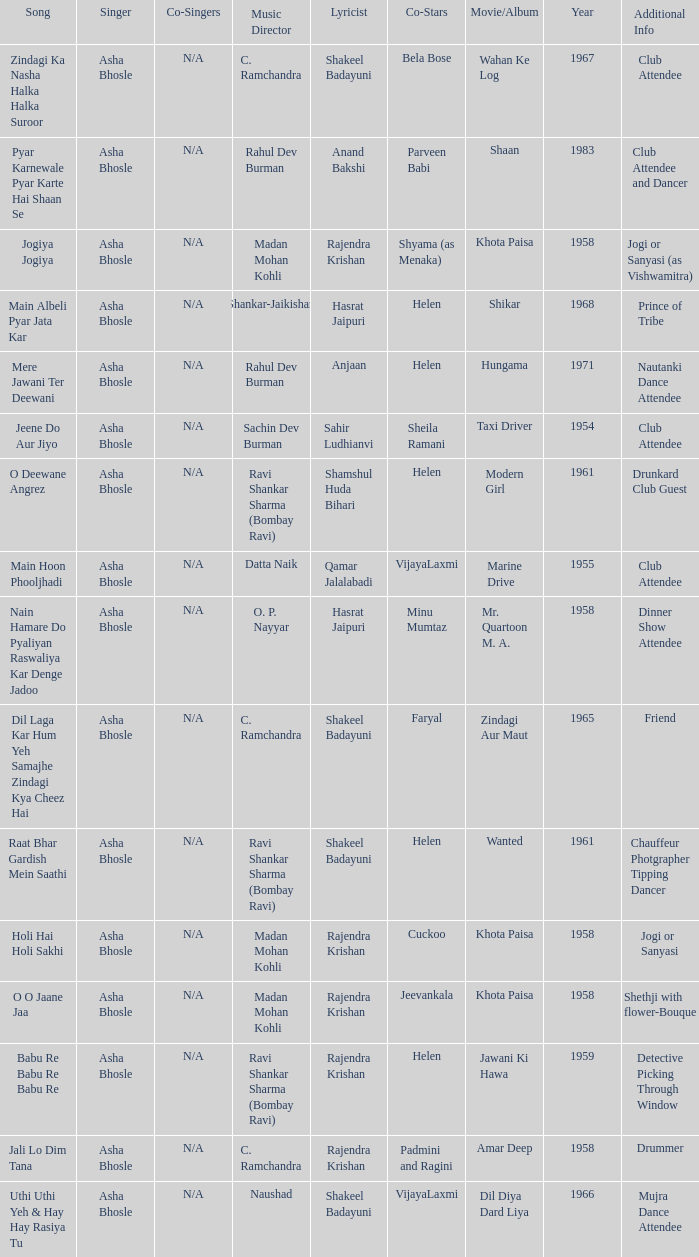Write the full table. {'header': ['Song', 'Singer', 'Co-Singers', 'Music Director', 'Lyricist', 'Co-Stars', 'Movie/Album', 'Year', 'Additional Info'], 'rows': [['Zindagi Ka Nasha Halka Halka Suroor', 'Asha Bhosle', 'N/A', 'C. Ramchandra', 'Shakeel Badayuni', 'Bela Bose', 'Wahan Ke Log', '1967', 'Club Attendee'], ['Pyar Karnewale Pyar Karte Hai Shaan Se', 'Asha Bhosle', 'N/A', 'Rahul Dev Burman', 'Anand Bakshi', 'Parveen Babi', 'Shaan', '1983', 'Club Attendee and Dancer'], ['Jogiya Jogiya', 'Asha Bhosle', 'N/A', 'Madan Mohan Kohli', 'Rajendra Krishan', 'Shyama (as Menaka)', 'Khota Paisa', '1958', 'Jogi or Sanyasi (as Vishwamitra)'], ['Main Albeli Pyar Jata Kar', 'Asha Bhosle', 'N/A', 'Shankar-Jaikishan', 'Hasrat Jaipuri', 'Helen', 'Shikar', '1968', 'Prince of Tribe'], ['Mere Jawani Ter Deewani', 'Asha Bhosle', 'N/A', 'Rahul Dev Burman', 'Anjaan', 'Helen', 'Hungama', '1971', 'Nautanki Dance Attendee'], ['Jeene Do Aur Jiyo', 'Asha Bhosle', 'N/A', 'Sachin Dev Burman', 'Sahir Ludhianvi', 'Sheila Ramani', 'Taxi Driver', '1954', 'Club Attendee'], ['O Deewane Angrez', 'Asha Bhosle', 'N/A', 'Ravi Shankar Sharma (Bombay Ravi)', 'Shamshul Huda Bihari', 'Helen', 'Modern Girl', '1961', 'Drunkard Club Guest'], ['Main Hoon Phooljhadi', 'Asha Bhosle', 'N/A', 'Datta Naik', 'Qamar Jalalabadi', 'VijayaLaxmi', 'Marine Drive', '1955', 'Club Attendee'], ['Nain Hamare Do Pyaliyan Raswaliya Kar Denge Jadoo', 'Asha Bhosle', 'N/A', 'O. P. Nayyar', 'Hasrat Jaipuri', 'Minu Mumtaz', 'Mr. Quartoon M. A.', '1958', 'Dinner Show Attendee'], ['Dil Laga Kar Hum Yeh Samajhe Zindagi Kya Cheez Hai', 'Asha Bhosle', 'N/A', 'C. Ramchandra', 'Shakeel Badayuni', 'Faryal', 'Zindagi Aur Maut', '1965', 'Friend'], ['Raat Bhar Gardish Mein Saathi', 'Asha Bhosle', 'N/A', 'Ravi Shankar Sharma (Bombay Ravi)', 'Shakeel Badayuni', 'Helen', 'Wanted', '1961', 'Chauffeur Photgrapher Tipping Dancer'], ['Holi Hai Holi Sakhi', 'Asha Bhosle', 'N/A', 'Madan Mohan Kohli', 'Rajendra Krishan', 'Cuckoo', 'Khota Paisa', '1958', 'Jogi or Sanyasi'], ['O O Jaane Jaa', 'Asha Bhosle', 'N/A', 'Madan Mohan Kohli', 'Rajendra Krishan', 'Jeevankala', 'Khota Paisa', '1958', 'Shethji with flower-Bouque'], ['Babu Re Babu Re Babu Re', 'Asha Bhosle', 'N/A', 'Ravi Shankar Sharma (Bombay Ravi)', 'Rajendra Krishan', 'Helen', 'Jawani Ki Hawa', '1959', 'Detective Picking Through Window'], ['Jali Lo Dim Tana', 'Asha Bhosle', 'N/A', 'C. Ramchandra', 'Rajendra Krishan', 'Padmini and Ragini', 'Amar Deep', '1958', 'Drummer'], ['Uthi Uthi Yeh & Hay Hay Rasiya Tu', 'Asha Bhosle', 'N/A', 'Naushad', 'Shakeel Badayuni', 'VijayaLaxmi', 'Dil Diya Dard Liya', '1966', 'Mujra Dance Attendee']]} What movie did Bela Bose co-star in? Wahan Ke Log. 